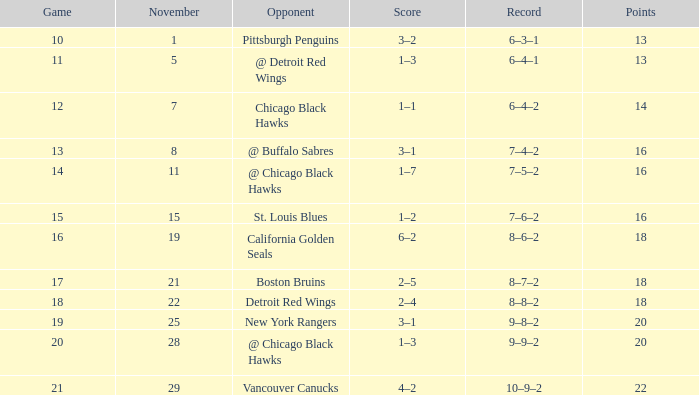Can you give me this table as a dict? {'header': ['Game', 'November', 'Opponent', 'Score', 'Record', 'Points'], 'rows': [['10', '1', 'Pittsburgh Penguins', '3–2', '6–3–1', '13'], ['11', '5', '@ Detroit Red Wings', '1–3', '6–4–1', '13'], ['12', '7', 'Chicago Black Hawks', '1–1', '6–4–2', '14'], ['13', '8', '@ Buffalo Sabres', '3–1', '7–4–2', '16'], ['14', '11', '@ Chicago Black Hawks', '1–7', '7–5–2', '16'], ['15', '15', 'St. Louis Blues', '1–2', '7–6–2', '16'], ['16', '19', 'California Golden Seals', '6–2', '8–6–2', '18'], ['17', '21', 'Boston Bruins', '2–5', '8–7–2', '18'], ['18', '22', 'Detroit Red Wings', '2–4', '8–8–2', '18'], ['19', '25', 'New York Rangers', '3–1', '9–8–2', '20'], ['20', '28', '@ Chicago Black Hawks', '1–3', '9–9–2', '20'], ['21', '29', 'Vancouver Canucks', '4–2', '10–9–2', '22']]} Which opponent has points less than 18, and a november greater than 11? St. Louis Blues. 